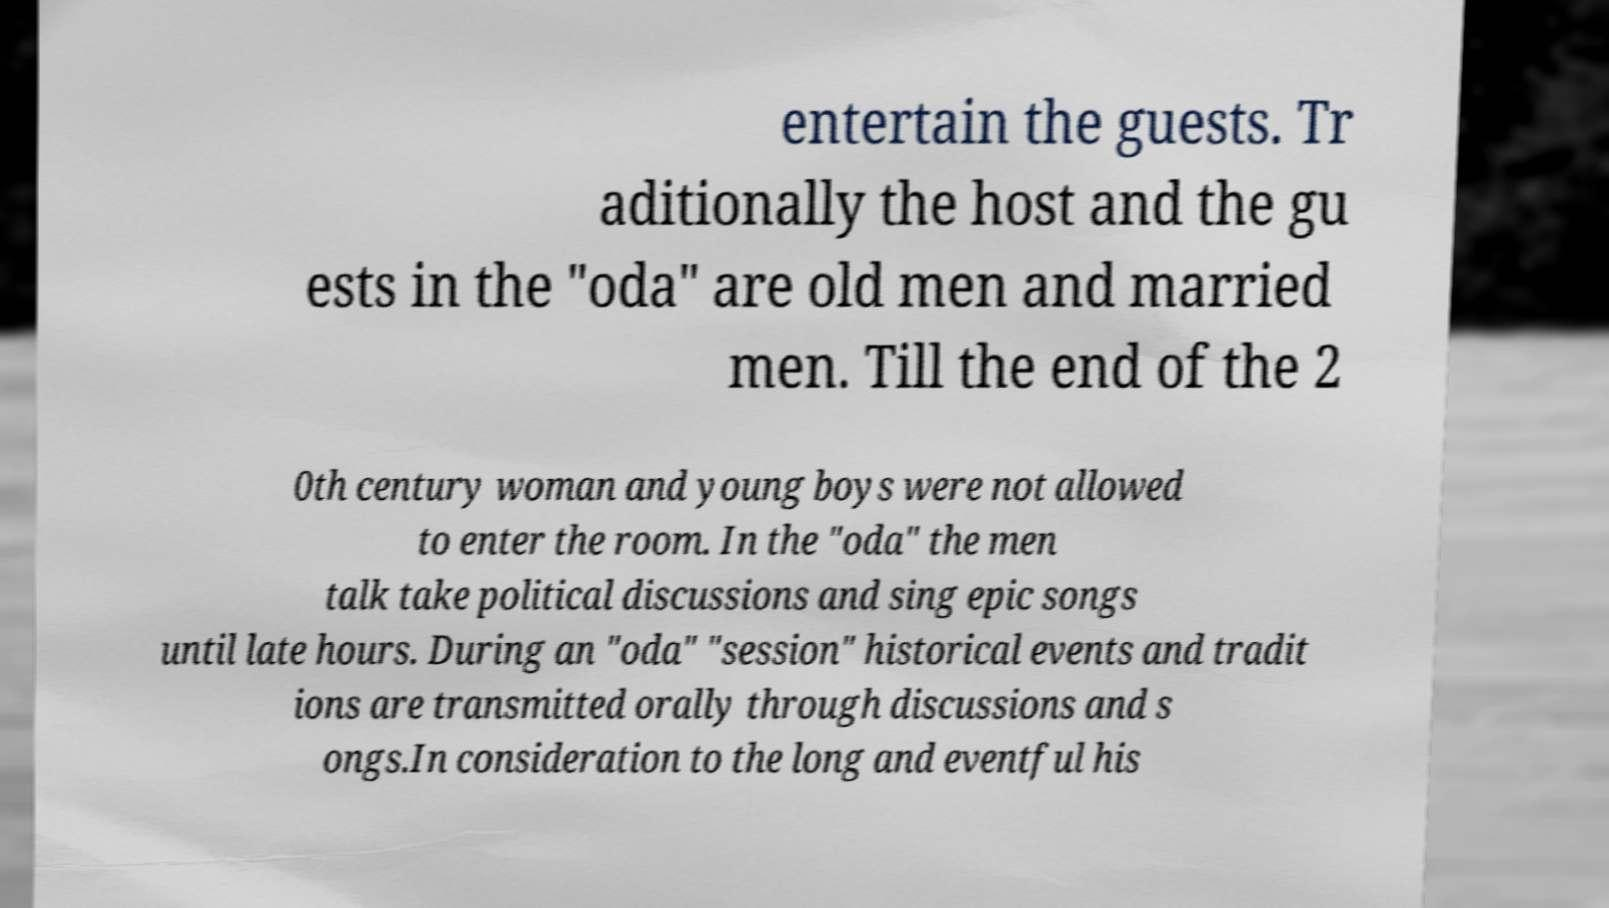Please identify and transcribe the text found in this image. entertain the guests. Tr aditionally the host and the gu ests in the "oda" are old men and married men. Till the end of the 2 0th century woman and young boys were not allowed to enter the room. In the "oda" the men talk take political discussions and sing epic songs until late hours. During an "oda" "session" historical events and tradit ions are transmitted orally through discussions and s ongs.In consideration to the long and eventful his 